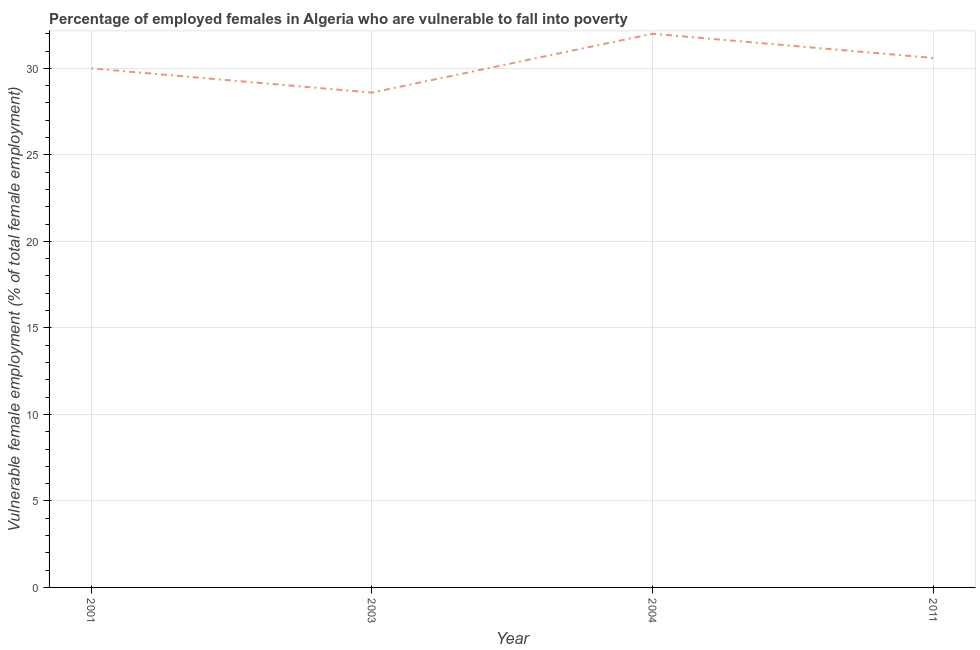What is the percentage of employed females who are vulnerable to fall into poverty in 2003?
Offer a very short reply. 28.6. Across all years, what is the maximum percentage of employed females who are vulnerable to fall into poverty?
Your answer should be very brief. 32. Across all years, what is the minimum percentage of employed females who are vulnerable to fall into poverty?
Keep it short and to the point. 28.6. In which year was the percentage of employed females who are vulnerable to fall into poverty maximum?
Provide a succinct answer. 2004. What is the sum of the percentage of employed females who are vulnerable to fall into poverty?
Make the answer very short. 121.2. What is the difference between the percentage of employed females who are vulnerable to fall into poverty in 2001 and 2003?
Your answer should be very brief. 1.4. What is the average percentage of employed females who are vulnerable to fall into poverty per year?
Your answer should be very brief. 30.3. What is the median percentage of employed females who are vulnerable to fall into poverty?
Give a very brief answer. 30.3. What is the ratio of the percentage of employed females who are vulnerable to fall into poverty in 2001 to that in 2011?
Offer a terse response. 0.98. Is the percentage of employed females who are vulnerable to fall into poverty in 2001 less than that in 2011?
Ensure brevity in your answer.  Yes. Is the difference between the percentage of employed females who are vulnerable to fall into poverty in 2001 and 2003 greater than the difference between any two years?
Ensure brevity in your answer.  No. What is the difference between the highest and the second highest percentage of employed females who are vulnerable to fall into poverty?
Keep it short and to the point. 1.4. Is the sum of the percentage of employed females who are vulnerable to fall into poverty in 2003 and 2004 greater than the maximum percentage of employed females who are vulnerable to fall into poverty across all years?
Your answer should be compact. Yes. What is the difference between the highest and the lowest percentage of employed females who are vulnerable to fall into poverty?
Provide a succinct answer. 3.4. In how many years, is the percentage of employed females who are vulnerable to fall into poverty greater than the average percentage of employed females who are vulnerable to fall into poverty taken over all years?
Make the answer very short. 2. How many lines are there?
Your answer should be compact. 1. How many years are there in the graph?
Provide a succinct answer. 4. Does the graph contain grids?
Ensure brevity in your answer.  Yes. What is the title of the graph?
Your answer should be compact. Percentage of employed females in Algeria who are vulnerable to fall into poverty. What is the label or title of the X-axis?
Your answer should be very brief. Year. What is the label or title of the Y-axis?
Provide a short and direct response. Vulnerable female employment (% of total female employment). What is the Vulnerable female employment (% of total female employment) in 2003?
Your response must be concise. 28.6. What is the Vulnerable female employment (% of total female employment) of 2011?
Give a very brief answer. 30.6. What is the difference between the Vulnerable female employment (% of total female employment) in 2001 and 2003?
Your answer should be compact. 1.4. What is the difference between the Vulnerable female employment (% of total female employment) in 2001 and 2004?
Provide a short and direct response. -2. What is the difference between the Vulnerable female employment (% of total female employment) in 2003 and 2004?
Provide a succinct answer. -3.4. What is the difference between the Vulnerable female employment (% of total female employment) in 2003 and 2011?
Ensure brevity in your answer.  -2. What is the ratio of the Vulnerable female employment (% of total female employment) in 2001 to that in 2003?
Offer a terse response. 1.05. What is the ratio of the Vulnerable female employment (% of total female employment) in 2001 to that in 2004?
Keep it short and to the point. 0.94. What is the ratio of the Vulnerable female employment (% of total female employment) in 2003 to that in 2004?
Keep it short and to the point. 0.89. What is the ratio of the Vulnerable female employment (% of total female employment) in 2003 to that in 2011?
Your answer should be compact. 0.94. What is the ratio of the Vulnerable female employment (% of total female employment) in 2004 to that in 2011?
Give a very brief answer. 1.05. 